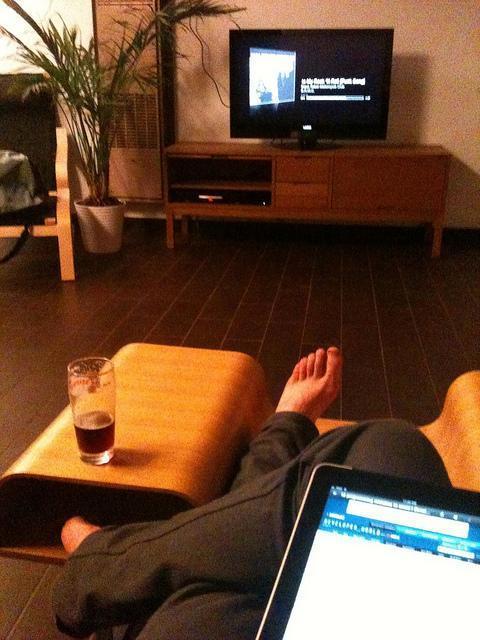Is the statement "The person is left of the potted plant." accurate regarding the image?
Answer yes or no. No. 